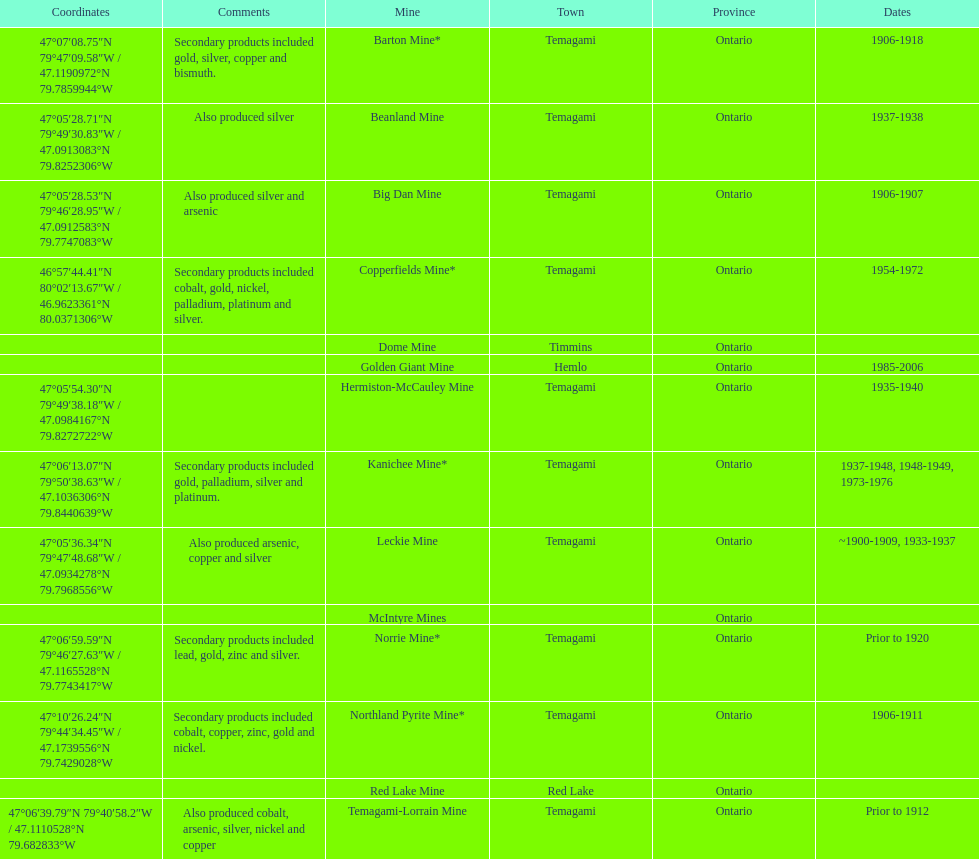Name a gold mine that was open at least 10 years. Barton Mine. 